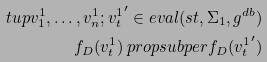Convert formula to latex. <formula><loc_0><loc_0><loc_500><loc_500>\ t u p { v ^ { 1 } _ { 1 } , \dots , v ^ { 1 } _ { n } ; { v ^ { 1 } _ { t } } ^ { \prime } } \in e v a l ( s t , \Sigma _ { 1 } , g ^ { d b } ) \\ f _ { D } ( v ^ { 1 } _ { t } ) \ p r o p s u b p e r f _ { D } ( { v ^ { 1 } _ { t } } ^ { \prime } )</formula> 